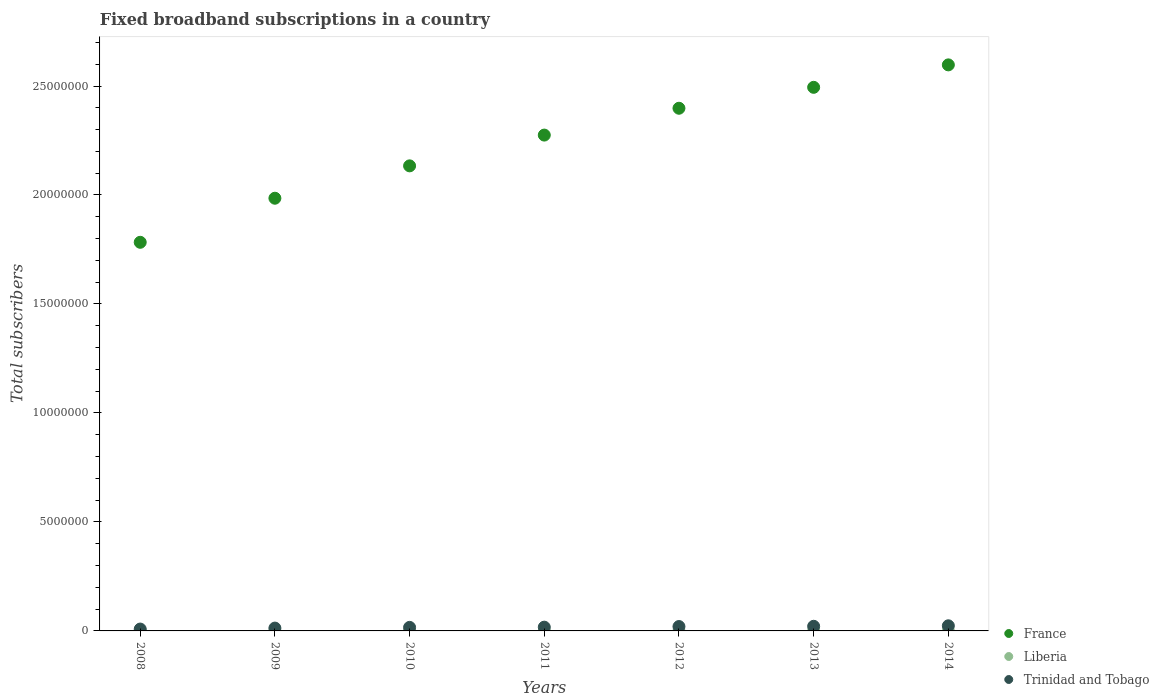Is the number of dotlines equal to the number of legend labels?
Keep it short and to the point. Yes. What is the number of broadband subscriptions in Liberia in 2012?
Your answer should be compact. 524. Across all years, what is the maximum number of broadband subscriptions in France?
Your answer should be compact. 2.60e+07. Across all years, what is the minimum number of broadband subscriptions in France?
Keep it short and to the point. 1.78e+07. In which year was the number of broadband subscriptions in France maximum?
Your answer should be very brief. 2014. In which year was the number of broadband subscriptions in France minimum?
Your response must be concise. 2008. What is the total number of broadband subscriptions in France in the graph?
Keep it short and to the point. 1.57e+08. What is the difference between the number of broadband subscriptions in Liberia in 2011 and that in 2013?
Provide a succinct answer. -5017. What is the difference between the number of broadband subscriptions in France in 2014 and the number of broadband subscriptions in Liberia in 2010?
Keep it short and to the point. 2.60e+07. What is the average number of broadband subscriptions in Trinidad and Tobago per year?
Offer a terse response. 1.71e+05. In the year 2011, what is the difference between the number of broadband subscriptions in Trinidad and Tobago and number of broadband subscriptions in Liberia?
Make the answer very short. 1.72e+05. In how many years, is the number of broadband subscriptions in France greater than 18000000?
Provide a succinct answer. 6. What is the ratio of the number of broadband subscriptions in Liberia in 2010 to that in 2014?
Keep it short and to the point. 0.03. Is the number of broadband subscriptions in France in 2009 less than that in 2012?
Give a very brief answer. Yes. Is the difference between the number of broadband subscriptions in Trinidad and Tobago in 2011 and 2012 greater than the difference between the number of broadband subscriptions in Liberia in 2011 and 2012?
Provide a short and direct response. No. What is the difference between the highest and the second highest number of broadband subscriptions in Liberia?
Your response must be concise. 920. What is the difference between the highest and the lowest number of broadband subscriptions in Liberia?
Your answer should be very brief. 5937. Is the sum of the number of broadband subscriptions in Liberia in 2009 and 2010 greater than the maximum number of broadband subscriptions in France across all years?
Your response must be concise. No. Is it the case that in every year, the sum of the number of broadband subscriptions in Trinidad and Tobago and number of broadband subscriptions in Liberia  is greater than the number of broadband subscriptions in France?
Give a very brief answer. No. Is the number of broadband subscriptions in France strictly less than the number of broadband subscriptions in Trinidad and Tobago over the years?
Keep it short and to the point. No. What is the difference between two consecutive major ticks on the Y-axis?
Your answer should be very brief. 5.00e+06. Are the values on the major ticks of Y-axis written in scientific E-notation?
Your response must be concise. No. Does the graph contain any zero values?
Provide a succinct answer. No. Does the graph contain grids?
Ensure brevity in your answer.  No. Where does the legend appear in the graph?
Ensure brevity in your answer.  Bottom right. How are the legend labels stacked?
Provide a succinct answer. Vertical. What is the title of the graph?
Provide a succinct answer. Fixed broadband subscriptions in a country. Does "Macao" appear as one of the legend labels in the graph?
Provide a short and direct response. No. What is the label or title of the Y-axis?
Provide a succinct answer. Total subscribers. What is the Total subscribers of France in 2008?
Provide a succinct answer. 1.78e+07. What is the Total subscribers in Liberia in 2008?
Ensure brevity in your answer.  110. What is the Total subscribers in Trinidad and Tobago in 2008?
Provide a succinct answer. 8.54e+04. What is the Total subscribers of France in 2009?
Your answer should be very brief. 1.99e+07. What is the Total subscribers of Liberia in 2009?
Your answer should be compact. 150. What is the Total subscribers in Trinidad and Tobago in 2009?
Give a very brief answer. 1.30e+05. What is the Total subscribers in France in 2010?
Keep it short and to the point. 2.13e+07. What is the Total subscribers in Liberia in 2010?
Provide a short and direct response. 186. What is the Total subscribers of Trinidad and Tobago in 2010?
Your answer should be compact. 1.63e+05. What is the Total subscribers in France in 2011?
Keep it short and to the point. 2.27e+07. What is the Total subscribers of Trinidad and Tobago in 2011?
Keep it short and to the point. 1.72e+05. What is the Total subscribers in France in 2012?
Your answer should be compact. 2.40e+07. What is the Total subscribers in Liberia in 2012?
Your answer should be very brief. 524. What is the Total subscribers in Trinidad and Tobago in 2012?
Provide a succinct answer. 2.01e+05. What is the Total subscribers of France in 2013?
Provide a succinct answer. 2.49e+07. What is the Total subscribers in Liberia in 2013?
Provide a short and direct response. 5080. What is the Total subscribers in Trinidad and Tobago in 2013?
Provide a succinct answer. 2.12e+05. What is the Total subscribers of France in 2014?
Offer a terse response. 2.60e+07. What is the Total subscribers of Liberia in 2014?
Offer a terse response. 6000. What is the Total subscribers of Trinidad and Tobago in 2014?
Provide a succinct answer. 2.35e+05. Across all years, what is the maximum Total subscribers in France?
Make the answer very short. 2.60e+07. Across all years, what is the maximum Total subscribers in Liberia?
Provide a short and direct response. 6000. Across all years, what is the maximum Total subscribers of Trinidad and Tobago?
Your answer should be compact. 2.35e+05. Across all years, what is the minimum Total subscribers of France?
Your answer should be very brief. 1.78e+07. Across all years, what is the minimum Total subscribers in Liberia?
Provide a short and direct response. 63. Across all years, what is the minimum Total subscribers in Trinidad and Tobago?
Your answer should be compact. 8.54e+04. What is the total Total subscribers in France in the graph?
Give a very brief answer. 1.57e+08. What is the total Total subscribers in Liberia in the graph?
Provide a succinct answer. 1.21e+04. What is the total Total subscribers of Trinidad and Tobago in the graph?
Your answer should be compact. 1.20e+06. What is the difference between the Total subscribers in France in 2008 and that in 2009?
Keep it short and to the point. -2.02e+06. What is the difference between the Total subscribers of Liberia in 2008 and that in 2009?
Your response must be concise. -40. What is the difference between the Total subscribers in Trinidad and Tobago in 2008 and that in 2009?
Provide a succinct answer. -4.46e+04. What is the difference between the Total subscribers of France in 2008 and that in 2010?
Your answer should be compact. -3.51e+06. What is the difference between the Total subscribers in Liberia in 2008 and that in 2010?
Your answer should be very brief. -76. What is the difference between the Total subscribers of Trinidad and Tobago in 2008 and that in 2010?
Offer a very short reply. -7.74e+04. What is the difference between the Total subscribers in France in 2008 and that in 2011?
Ensure brevity in your answer.  -4.92e+06. What is the difference between the Total subscribers of Liberia in 2008 and that in 2011?
Provide a succinct answer. 47. What is the difference between the Total subscribers in Trinidad and Tobago in 2008 and that in 2011?
Offer a terse response. -8.69e+04. What is the difference between the Total subscribers of France in 2008 and that in 2012?
Offer a terse response. -6.15e+06. What is the difference between the Total subscribers in Liberia in 2008 and that in 2012?
Give a very brief answer. -414. What is the difference between the Total subscribers in Trinidad and Tobago in 2008 and that in 2012?
Your answer should be very brief. -1.16e+05. What is the difference between the Total subscribers in France in 2008 and that in 2013?
Provide a succinct answer. -7.11e+06. What is the difference between the Total subscribers in Liberia in 2008 and that in 2013?
Your response must be concise. -4970. What is the difference between the Total subscribers in Trinidad and Tobago in 2008 and that in 2013?
Make the answer very short. -1.27e+05. What is the difference between the Total subscribers of France in 2008 and that in 2014?
Make the answer very short. -8.14e+06. What is the difference between the Total subscribers of Liberia in 2008 and that in 2014?
Offer a very short reply. -5890. What is the difference between the Total subscribers of Trinidad and Tobago in 2008 and that in 2014?
Offer a very short reply. -1.49e+05. What is the difference between the Total subscribers in France in 2009 and that in 2010?
Ensure brevity in your answer.  -1.48e+06. What is the difference between the Total subscribers in Liberia in 2009 and that in 2010?
Your response must be concise. -36. What is the difference between the Total subscribers in Trinidad and Tobago in 2009 and that in 2010?
Ensure brevity in your answer.  -3.28e+04. What is the difference between the Total subscribers of France in 2009 and that in 2011?
Ensure brevity in your answer.  -2.90e+06. What is the difference between the Total subscribers of Liberia in 2009 and that in 2011?
Provide a succinct answer. 87. What is the difference between the Total subscribers of Trinidad and Tobago in 2009 and that in 2011?
Keep it short and to the point. -4.23e+04. What is the difference between the Total subscribers of France in 2009 and that in 2012?
Make the answer very short. -4.13e+06. What is the difference between the Total subscribers in Liberia in 2009 and that in 2012?
Your answer should be compact. -374. What is the difference between the Total subscribers in Trinidad and Tobago in 2009 and that in 2012?
Your answer should be very brief. -7.14e+04. What is the difference between the Total subscribers of France in 2009 and that in 2013?
Keep it short and to the point. -5.09e+06. What is the difference between the Total subscribers of Liberia in 2009 and that in 2013?
Ensure brevity in your answer.  -4930. What is the difference between the Total subscribers in Trinidad and Tobago in 2009 and that in 2013?
Keep it short and to the point. -8.24e+04. What is the difference between the Total subscribers of France in 2009 and that in 2014?
Offer a terse response. -6.12e+06. What is the difference between the Total subscribers of Liberia in 2009 and that in 2014?
Your response must be concise. -5850. What is the difference between the Total subscribers in Trinidad and Tobago in 2009 and that in 2014?
Your answer should be compact. -1.05e+05. What is the difference between the Total subscribers in France in 2010 and that in 2011?
Your response must be concise. -1.41e+06. What is the difference between the Total subscribers of Liberia in 2010 and that in 2011?
Give a very brief answer. 123. What is the difference between the Total subscribers in Trinidad and Tobago in 2010 and that in 2011?
Your answer should be compact. -9468. What is the difference between the Total subscribers of France in 2010 and that in 2012?
Your answer should be very brief. -2.64e+06. What is the difference between the Total subscribers in Liberia in 2010 and that in 2012?
Keep it short and to the point. -338. What is the difference between the Total subscribers of Trinidad and Tobago in 2010 and that in 2012?
Keep it short and to the point. -3.86e+04. What is the difference between the Total subscribers in France in 2010 and that in 2013?
Your answer should be very brief. -3.60e+06. What is the difference between the Total subscribers of Liberia in 2010 and that in 2013?
Keep it short and to the point. -4894. What is the difference between the Total subscribers of Trinidad and Tobago in 2010 and that in 2013?
Ensure brevity in your answer.  -4.96e+04. What is the difference between the Total subscribers of France in 2010 and that in 2014?
Make the answer very short. -4.63e+06. What is the difference between the Total subscribers of Liberia in 2010 and that in 2014?
Make the answer very short. -5814. What is the difference between the Total subscribers of Trinidad and Tobago in 2010 and that in 2014?
Keep it short and to the point. -7.20e+04. What is the difference between the Total subscribers of France in 2011 and that in 2012?
Give a very brief answer. -1.23e+06. What is the difference between the Total subscribers in Liberia in 2011 and that in 2012?
Offer a very short reply. -461. What is the difference between the Total subscribers of Trinidad and Tobago in 2011 and that in 2012?
Offer a very short reply. -2.91e+04. What is the difference between the Total subscribers of France in 2011 and that in 2013?
Keep it short and to the point. -2.19e+06. What is the difference between the Total subscribers of Liberia in 2011 and that in 2013?
Your answer should be very brief. -5017. What is the difference between the Total subscribers of Trinidad and Tobago in 2011 and that in 2013?
Make the answer very short. -4.02e+04. What is the difference between the Total subscribers of France in 2011 and that in 2014?
Your response must be concise. -3.22e+06. What is the difference between the Total subscribers of Liberia in 2011 and that in 2014?
Your answer should be very brief. -5937. What is the difference between the Total subscribers of Trinidad and Tobago in 2011 and that in 2014?
Ensure brevity in your answer.  -6.25e+04. What is the difference between the Total subscribers in France in 2012 and that in 2013?
Give a very brief answer. -9.60e+05. What is the difference between the Total subscribers of Liberia in 2012 and that in 2013?
Make the answer very short. -4556. What is the difference between the Total subscribers of Trinidad and Tobago in 2012 and that in 2013?
Provide a short and direct response. -1.11e+04. What is the difference between the Total subscribers of France in 2012 and that in 2014?
Your answer should be compact. -1.99e+06. What is the difference between the Total subscribers of Liberia in 2012 and that in 2014?
Your response must be concise. -5476. What is the difference between the Total subscribers in Trinidad and Tobago in 2012 and that in 2014?
Offer a terse response. -3.34e+04. What is the difference between the Total subscribers in France in 2013 and that in 2014?
Provide a short and direct response. -1.03e+06. What is the difference between the Total subscribers in Liberia in 2013 and that in 2014?
Ensure brevity in your answer.  -920. What is the difference between the Total subscribers of Trinidad and Tobago in 2013 and that in 2014?
Make the answer very short. -2.23e+04. What is the difference between the Total subscribers in France in 2008 and the Total subscribers in Liberia in 2009?
Your response must be concise. 1.78e+07. What is the difference between the Total subscribers of France in 2008 and the Total subscribers of Trinidad and Tobago in 2009?
Your answer should be compact. 1.77e+07. What is the difference between the Total subscribers in Liberia in 2008 and the Total subscribers in Trinidad and Tobago in 2009?
Give a very brief answer. -1.30e+05. What is the difference between the Total subscribers in France in 2008 and the Total subscribers in Liberia in 2010?
Ensure brevity in your answer.  1.78e+07. What is the difference between the Total subscribers in France in 2008 and the Total subscribers in Trinidad and Tobago in 2010?
Your answer should be very brief. 1.77e+07. What is the difference between the Total subscribers of Liberia in 2008 and the Total subscribers of Trinidad and Tobago in 2010?
Provide a short and direct response. -1.63e+05. What is the difference between the Total subscribers of France in 2008 and the Total subscribers of Liberia in 2011?
Offer a very short reply. 1.78e+07. What is the difference between the Total subscribers of France in 2008 and the Total subscribers of Trinidad and Tobago in 2011?
Make the answer very short. 1.77e+07. What is the difference between the Total subscribers of Liberia in 2008 and the Total subscribers of Trinidad and Tobago in 2011?
Your answer should be very brief. -1.72e+05. What is the difference between the Total subscribers of France in 2008 and the Total subscribers of Liberia in 2012?
Keep it short and to the point. 1.78e+07. What is the difference between the Total subscribers in France in 2008 and the Total subscribers in Trinidad and Tobago in 2012?
Provide a succinct answer. 1.76e+07. What is the difference between the Total subscribers of Liberia in 2008 and the Total subscribers of Trinidad and Tobago in 2012?
Your answer should be very brief. -2.01e+05. What is the difference between the Total subscribers in France in 2008 and the Total subscribers in Liberia in 2013?
Keep it short and to the point. 1.78e+07. What is the difference between the Total subscribers of France in 2008 and the Total subscribers of Trinidad and Tobago in 2013?
Make the answer very short. 1.76e+07. What is the difference between the Total subscribers of Liberia in 2008 and the Total subscribers of Trinidad and Tobago in 2013?
Offer a terse response. -2.12e+05. What is the difference between the Total subscribers in France in 2008 and the Total subscribers in Liberia in 2014?
Make the answer very short. 1.78e+07. What is the difference between the Total subscribers of France in 2008 and the Total subscribers of Trinidad and Tobago in 2014?
Your response must be concise. 1.76e+07. What is the difference between the Total subscribers in Liberia in 2008 and the Total subscribers in Trinidad and Tobago in 2014?
Provide a succinct answer. -2.35e+05. What is the difference between the Total subscribers in France in 2009 and the Total subscribers in Liberia in 2010?
Make the answer very short. 1.99e+07. What is the difference between the Total subscribers in France in 2009 and the Total subscribers in Trinidad and Tobago in 2010?
Your answer should be very brief. 1.97e+07. What is the difference between the Total subscribers of Liberia in 2009 and the Total subscribers of Trinidad and Tobago in 2010?
Your response must be concise. -1.63e+05. What is the difference between the Total subscribers in France in 2009 and the Total subscribers in Liberia in 2011?
Ensure brevity in your answer.  1.99e+07. What is the difference between the Total subscribers of France in 2009 and the Total subscribers of Trinidad and Tobago in 2011?
Offer a terse response. 1.97e+07. What is the difference between the Total subscribers in Liberia in 2009 and the Total subscribers in Trinidad and Tobago in 2011?
Provide a short and direct response. -1.72e+05. What is the difference between the Total subscribers in France in 2009 and the Total subscribers in Liberia in 2012?
Offer a terse response. 1.99e+07. What is the difference between the Total subscribers of France in 2009 and the Total subscribers of Trinidad and Tobago in 2012?
Your response must be concise. 1.97e+07. What is the difference between the Total subscribers of Liberia in 2009 and the Total subscribers of Trinidad and Tobago in 2012?
Give a very brief answer. -2.01e+05. What is the difference between the Total subscribers of France in 2009 and the Total subscribers of Liberia in 2013?
Offer a terse response. 1.98e+07. What is the difference between the Total subscribers in France in 2009 and the Total subscribers in Trinidad and Tobago in 2013?
Your response must be concise. 1.96e+07. What is the difference between the Total subscribers of Liberia in 2009 and the Total subscribers of Trinidad and Tobago in 2013?
Provide a short and direct response. -2.12e+05. What is the difference between the Total subscribers of France in 2009 and the Total subscribers of Liberia in 2014?
Provide a succinct answer. 1.98e+07. What is the difference between the Total subscribers of France in 2009 and the Total subscribers of Trinidad and Tobago in 2014?
Offer a terse response. 1.96e+07. What is the difference between the Total subscribers in Liberia in 2009 and the Total subscribers in Trinidad and Tobago in 2014?
Your answer should be compact. -2.35e+05. What is the difference between the Total subscribers of France in 2010 and the Total subscribers of Liberia in 2011?
Offer a very short reply. 2.13e+07. What is the difference between the Total subscribers in France in 2010 and the Total subscribers in Trinidad and Tobago in 2011?
Offer a terse response. 2.12e+07. What is the difference between the Total subscribers of Liberia in 2010 and the Total subscribers of Trinidad and Tobago in 2011?
Give a very brief answer. -1.72e+05. What is the difference between the Total subscribers of France in 2010 and the Total subscribers of Liberia in 2012?
Keep it short and to the point. 2.13e+07. What is the difference between the Total subscribers in France in 2010 and the Total subscribers in Trinidad and Tobago in 2012?
Your response must be concise. 2.11e+07. What is the difference between the Total subscribers in Liberia in 2010 and the Total subscribers in Trinidad and Tobago in 2012?
Offer a terse response. -2.01e+05. What is the difference between the Total subscribers of France in 2010 and the Total subscribers of Liberia in 2013?
Make the answer very short. 2.13e+07. What is the difference between the Total subscribers of France in 2010 and the Total subscribers of Trinidad and Tobago in 2013?
Keep it short and to the point. 2.11e+07. What is the difference between the Total subscribers of Liberia in 2010 and the Total subscribers of Trinidad and Tobago in 2013?
Make the answer very short. -2.12e+05. What is the difference between the Total subscribers in France in 2010 and the Total subscribers in Liberia in 2014?
Ensure brevity in your answer.  2.13e+07. What is the difference between the Total subscribers of France in 2010 and the Total subscribers of Trinidad and Tobago in 2014?
Make the answer very short. 2.11e+07. What is the difference between the Total subscribers of Liberia in 2010 and the Total subscribers of Trinidad and Tobago in 2014?
Your answer should be very brief. -2.35e+05. What is the difference between the Total subscribers of France in 2011 and the Total subscribers of Liberia in 2012?
Provide a short and direct response. 2.27e+07. What is the difference between the Total subscribers of France in 2011 and the Total subscribers of Trinidad and Tobago in 2012?
Provide a short and direct response. 2.25e+07. What is the difference between the Total subscribers of Liberia in 2011 and the Total subscribers of Trinidad and Tobago in 2012?
Offer a terse response. -2.01e+05. What is the difference between the Total subscribers of France in 2011 and the Total subscribers of Liberia in 2013?
Ensure brevity in your answer.  2.27e+07. What is the difference between the Total subscribers in France in 2011 and the Total subscribers in Trinidad and Tobago in 2013?
Your response must be concise. 2.25e+07. What is the difference between the Total subscribers in Liberia in 2011 and the Total subscribers in Trinidad and Tobago in 2013?
Give a very brief answer. -2.12e+05. What is the difference between the Total subscribers of France in 2011 and the Total subscribers of Liberia in 2014?
Provide a succinct answer. 2.27e+07. What is the difference between the Total subscribers of France in 2011 and the Total subscribers of Trinidad and Tobago in 2014?
Your answer should be compact. 2.25e+07. What is the difference between the Total subscribers in Liberia in 2011 and the Total subscribers in Trinidad and Tobago in 2014?
Ensure brevity in your answer.  -2.35e+05. What is the difference between the Total subscribers in France in 2012 and the Total subscribers in Liberia in 2013?
Offer a very short reply. 2.40e+07. What is the difference between the Total subscribers in France in 2012 and the Total subscribers in Trinidad and Tobago in 2013?
Ensure brevity in your answer.  2.38e+07. What is the difference between the Total subscribers in Liberia in 2012 and the Total subscribers in Trinidad and Tobago in 2013?
Your answer should be compact. -2.12e+05. What is the difference between the Total subscribers in France in 2012 and the Total subscribers in Liberia in 2014?
Keep it short and to the point. 2.40e+07. What is the difference between the Total subscribers in France in 2012 and the Total subscribers in Trinidad and Tobago in 2014?
Offer a very short reply. 2.37e+07. What is the difference between the Total subscribers of Liberia in 2012 and the Total subscribers of Trinidad and Tobago in 2014?
Offer a terse response. -2.34e+05. What is the difference between the Total subscribers in France in 2013 and the Total subscribers in Liberia in 2014?
Keep it short and to the point. 2.49e+07. What is the difference between the Total subscribers in France in 2013 and the Total subscribers in Trinidad and Tobago in 2014?
Your response must be concise. 2.47e+07. What is the difference between the Total subscribers of Liberia in 2013 and the Total subscribers of Trinidad and Tobago in 2014?
Provide a short and direct response. -2.30e+05. What is the average Total subscribers in France per year?
Offer a very short reply. 2.24e+07. What is the average Total subscribers of Liberia per year?
Provide a short and direct response. 1730.43. What is the average Total subscribers in Trinidad and Tobago per year?
Provide a succinct answer. 1.71e+05. In the year 2008, what is the difference between the Total subscribers in France and Total subscribers in Liberia?
Offer a very short reply. 1.78e+07. In the year 2008, what is the difference between the Total subscribers in France and Total subscribers in Trinidad and Tobago?
Provide a short and direct response. 1.77e+07. In the year 2008, what is the difference between the Total subscribers in Liberia and Total subscribers in Trinidad and Tobago?
Offer a very short reply. -8.53e+04. In the year 2009, what is the difference between the Total subscribers in France and Total subscribers in Liberia?
Provide a short and direct response. 1.99e+07. In the year 2009, what is the difference between the Total subscribers of France and Total subscribers of Trinidad and Tobago?
Make the answer very short. 1.97e+07. In the year 2009, what is the difference between the Total subscribers in Liberia and Total subscribers in Trinidad and Tobago?
Your answer should be compact. -1.30e+05. In the year 2010, what is the difference between the Total subscribers of France and Total subscribers of Liberia?
Keep it short and to the point. 2.13e+07. In the year 2010, what is the difference between the Total subscribers in France and Total subscribers in Trinidad and Tobago?
Ensure brevity in your answer.  2.12e+07. In the year 2010, what is the difference between the Total subscribers in Liberia and Total subscribers in Trinidad and Tobago?
Keep it short and to the point. -1.63e+05. In the year 2011, what is the difference between the Total subscribers in France and Total subscribers in Liberia?
Provide a short and direct response. 2.27e+07. In the year 2011, what is the difference between the Total subscribers in France and Total subscribers in Trinidad and Tobago?
Keep it short and to the point. 2.26e+07. In the year 2011, what is the difference between the Total subscribers of Liberia and Total subscribers of Trinidad and Tobago?
Give a very brief answer. -1.72e+05. In the year 2012, what is the difference between the Total subscribers in France and Total subscribers in Liberia?
Provide a short and direct response. 2.40e+07. In the year 2012, what is the difference between the Total subscribers of France and Total subscribers of Trinidad and Tobago?
Offer a terse response. 2.38e+07. In the year 2012, what is the difference between the Total subscribers of Liberia and Total subscribers of Trinidad and Tobago?
Your answer should be very brief. -2.01e+05. In the year 2013, what is the difference between the Total subscribers in France and Total subscribers in Liberia?
Provide a short and direct response. 2.49e+07. In the year 2013, what is the difference between the Total subscribers of France and Total subscribers of Trinidad and Tobago?
Your answer should be very brief. 2.47e+07. In the year 2013, what is the difference between the Total subscribers of Liberia and Total subscribers of Trinidad and Tobago?
Offer a very short reply. -2.07e+05. In the year 2014, what is the difference between the Total subscribers in France and Total subscribers in Liberia?
Provide a succinct answer. 2.60e+07. In the year 2014, what is the difference between the Total subscribers of France and Total subscribers of Trinidad and Tobago?
Your response must be concise. 2.57e+07. In the year 2014, what is the difference between the Total subscribers of Liberia and Total subscribers of Trinidad and Tobago?
Provide a succinct answer. -2.29e+05. What is the ratio of the Total subscribers in France in 2008 to that in 2009?
Offer a terse response. 0.9. What is the ratio of the Total subscribers in Liberia in 2008 to that in 2009?
Your answer should be very brief. 0.73. What is the ratio of the Total subscribers of Trinidad and Tobago in 2008 to that in 2009?
Offer a very short reply. 0.66. What is the ratio of the Total subscribers of France in 2008 to that in 2010?
Your response must be concise. 0.84. What is the ratio of the Total subscribers of Liberia in 2008 to that in 2010?
Offer a very short reply. 0.59. What is the ratio of the Total subscribers of Trinidad and Tobago in 2008 to that in 2010?
Your answer should be compact. 0.52. What is the ratio of the Total subscribers of France in 2008 to that in 2011?
Provide a short and direct response. 0.78. What is the ratio of the Total subscribers in Liberia in 2008 to that in 2011?
Your answer should be very brief. 1.75. What is the ratio of the Total subscribers of Trinidad and Tobago in 2008 to that in 2011?
Your answer should be compact. 0.5. What is the ratio of the Total subscribers in France in 2008 to that in 2012?
Keep it short and to the point. 0.74. What is the ratio of the Total subscribers of Liberia in 2008 to that in 2012?
Provide a short and direct response. 0.21. What is the ratio of the Total subscribers in Trinidad and Tobago in 2008 to that in 2012?
Provide a short and direct response. 0.42. What is the ratio of the Total subscribers of France in 2008 to that in 2013?
Your response must be concise. 0.71. What is the ratio of the Total subscribers in Liberia in 2008 to that in 2013?
Make the answer very short. 0.02. What is the ratio of the Total subscribers of Trinidad and Tobago in 2008 to that in 2013?
Offer a very short reply. 0.4. What is the ratio of the Total subscribers of France in 2008 to that in 2014?
Make the answer very short. 0.69. What is the ratio of the Total subscribers in Liberia in 2008 to that in 2014?
Give a very brief answer. 0.02. What is the ratio of the Total subscribers in Trinidad and Tobago in 2008 to that in 2014?
Provide a short and direct response. 0.36. What is the ratio of the Total subscribers of France in 2009 to that in 2010?
Offer a terse response. 0.93. What is the ratio of the Total subscribers of Liberia in 2009 to that in 2010?
Ensure brevity in your answer.  0.81. What is the ratio of the Total subscribers in Trinidad and Tobago in 2009 to that in 2010?
Your response must be concise. 0.8. What is the ratio of the Total subscribers in France in 2009 to that in 2011?
Keep it short and to the point. 0.87. What is the ratio of the Total subscribers of Liberia in 2009 to that in 2011?
Your response must be concise. 2.38. What is the ratio of the Total subscribers in Trinidad and Tobago in 2009 to that in 2011?
Your response must be concise. 0.75. What is the ratio of the Total subscribers of France in 2009 to that in 2012?
Your answer should be compact. 0.83. What is the ratio of the Total subscribers in Liberia in 2009 to that in 2012?
Your answer should be very brief. 0.29. What is the ratio of the Total subscribers in Trinidad and Tobago in 2009 to that in 2012?
Make the answer very short. 0.65. What is the ratio of the Total subscribers of France in 2009 to that in 2013?
Your answer should be compact. 0.8. What is the ratio of the Total subscribers in Liberia in 2009 to that in 2013?
Make the answer very short. 0.03. What is the ratio of the Total subscribers of Trinidad and Tobago in 2009 to that in 2013?
Provide a short and direct response. 0.61. What is the ratio of the Total subscribers of France in 2009 to that in 2014?
Your response must be concise. 0.76. What is the ratio of the Total subscribers of Liberia in 2009 to that in 2014?
Ensure brevity in your answer.  0.03. What is the ratio of the Total subscribers in Trinidad and Tobago in 2009 to that in 2014?
Your response must be concise. 0.55. What is the ratio of the Total subscribers in France in 2010 to that in 2011?
Your answer should be very brief. 0.94. What is the ratio of the Total subscribers of Liberia in 2010 to that in 2011?
Keep it short and to the point. 2.95. What is the ratio of the Total subscribers of Trinidad and Tobago in 2010 to that in 2011?
Your answer should be compact. 0.95. What is the ratio of the Total subscribers of France in 2010 to that in 2012?
Offer a terse response. 0.89. What is the ratio of the Total subscribers in Liberia in 2010 to that in 2012?
Provide a succinct answer. 0.35. What is the ratio of the Total subscribers of Trinidad and Tobago in 2010 to that in 2012?
Give a very brief answer. 0.81. What is the ratio of the Total subscribers in France in 2010 to that in 2013?
Ensure brevity in your answer.  0.86. What is the ratio of the Total subscribers in Liberia in 2010 to that in 2013?
Your answer should be very brief. 0.04. What is the ratio of the Total subscribers of Trinidad and Tobago in 2010 to that in 2013?
Give a very brief answer. 0.77. What is the ratio of the Total subscribers of France in 2010 to that in 2014?
Offer a very short reply. 0.82. What is the ratio of the Total subscribers in Liberia in 2010 to that in 2014?
Give a very brief answer. 0.03. What is the ratio of the Total subscribers in Trinidad and Tobago in 2010 to that in 2014?
Offer a very short reply. 0.69. What is the ratio of the Total subscribers of France in 2011 to that in 2012?
Offer a very short reply. 0.95. What is the ratio of the Total subscribers of Liberia in 2011 to that in 2012?
Keep it short and to the point. 0.12. What is the ratio of the Total subscribers in Trinidad and Tobago in 2011 to that in 2012?
Ensure brevity in your answer.  0.86. What is the ratio of the Total subscribers of France in 2011 to that in 2013?
Offer a terse response. 0.91. What is the ratio of the Total subscribers of Liberia in 2011 to that in 2013?
Offer a terse response. 0.01. What is the ratio of the Total subscribers of Trinidad and Tobago in 2011 to that in 2013?
Provide a short and direct response. 0.81. What is the ratio of the Total subscribers in France in 2011 to that in 2014?
Ensure brevity in your answer.  0.88. What is the ratio of the Total subscribers of Liberia in 2011 to that in 2014?
Your answer should be compact. 0.01. What is the ratio of the Total subscribers in Trinidad and Tobago in 2011 to that in 2014?
Provide a short and direct response. 0.73. What is the ratio of the Total subscribers in France in 2012 to that in 2013?
Your answer should be compact. 0.96. What is the ratio of the Total subscribers of Liberia in 2012 to that in 2013?
Provide a succinct answer. 0.1. What is the ratio of the Total subscribers of Trinidad and Tobago in 2012 to that in 2013?
Give a very brief answer. 0.95. What is the ratio of the Total subscribers in France in 2012 to that in 2014?
Ensure brevity in your answer.  0.92. What is the ratio of the Total subscribers of Liberia in 2012 to that in 2014?
Keep it short and to the point. 0.09. What is the ratio of the Total subscribers of Trinidad and Tobago in 2012 to that in 2014?
Ensure brevity in your answer.  0.86. What is the ratio of the Total subscribers of France in 2013 to that in 2014?
Your answer should be very brief. 0.96. What is the ratio of the Total subscribers of Liberia in 2013 to that in 2014?
Provide a short and direct response. 0.85. What is the ratio of the Total subscribers in Trinidad and Tobago in 2013 to that in 2014?
Provide a succinct answer. 0.9. What is the difference between the highest and the second highest Total subscribers of France?
Your response must be concise. 1.03e+06. What is the difference between the highest and the second highest Total subscribers of Liberia?
Make the answer very short. 920. What is the difference between the highest and the second highest Total subscribers in Trinidad and Tobago?
Offer a very short reply. 2.23e+04. What is the difference between the highest and the lowest Total subscribers in France?
Provide a succinct answer. 8.14e+06. What is the difference between the highest and the lowest Total subscribers of Liberia?
Keep it short and to the point. 5937. What is the difference between the highest and the lowest Total subscribers of Trinidad and Tobago?
Offer a terse response. 1.49e+05. 